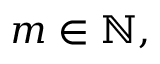Convert formula to latex. <formula><loc_0><loc_0><loc_500><loc_500>m \in \mathbb { N } ,</formula> 